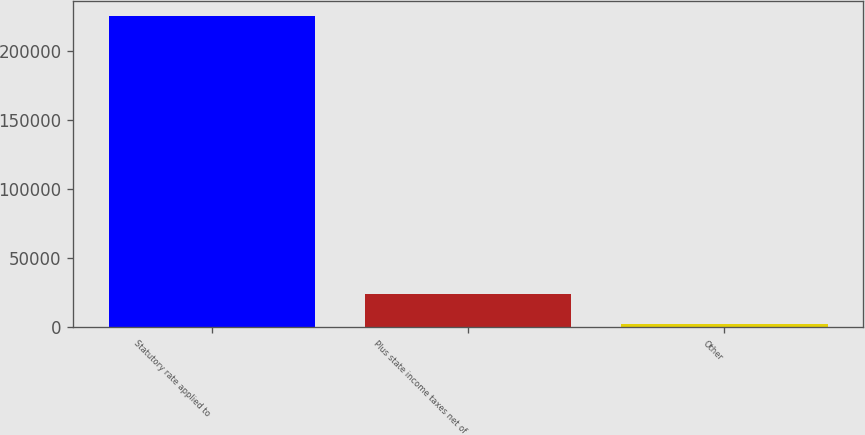Convert chart. <chart><loc_0><loc_0><loc_500><loc_500><bar_chart><fcel>Statutory rate applied to<fcel>Plus state income taxes net of<fcel>Other<nl><fcel>225458<fcel>24206.3<fcel>1845<nl></chart> 